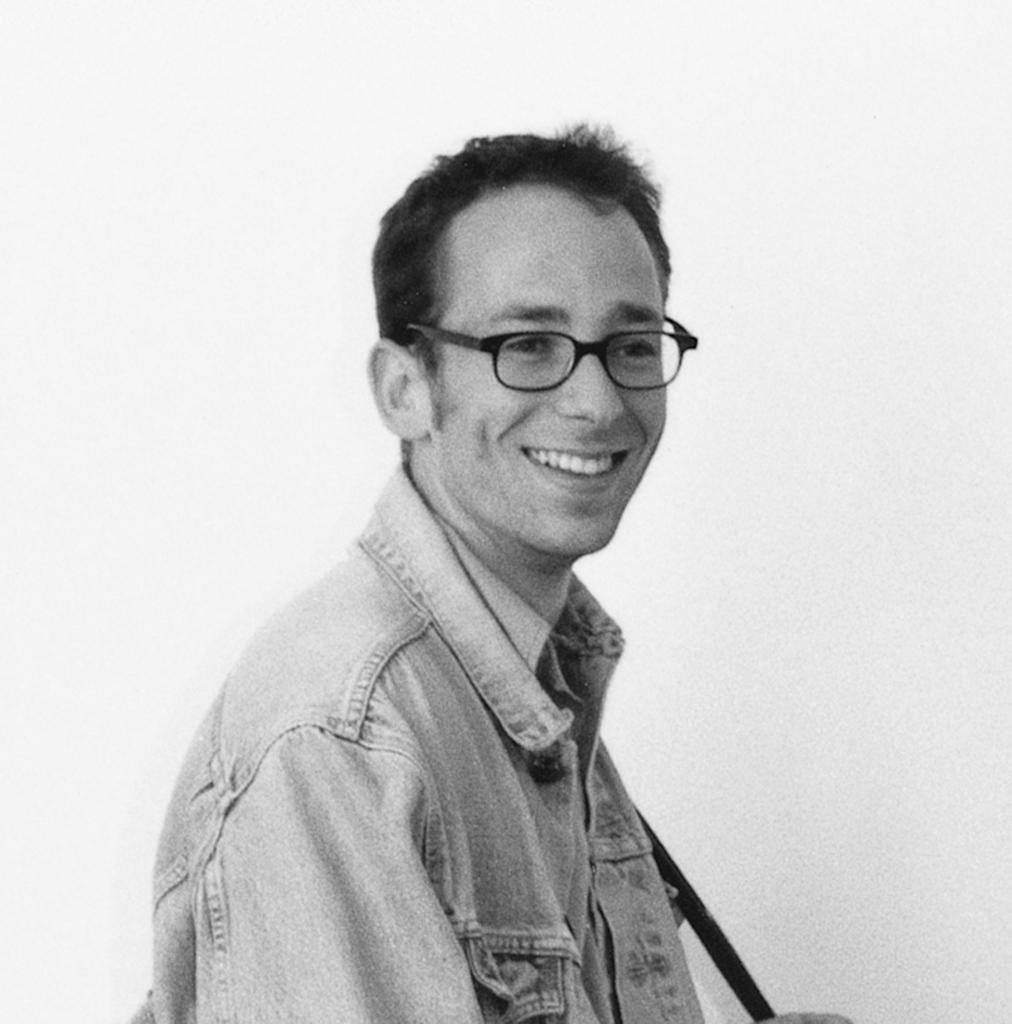How would you summarize this image in a sentence or two? As we can see in the image there is a white color wall and a man wearing spectacles. 